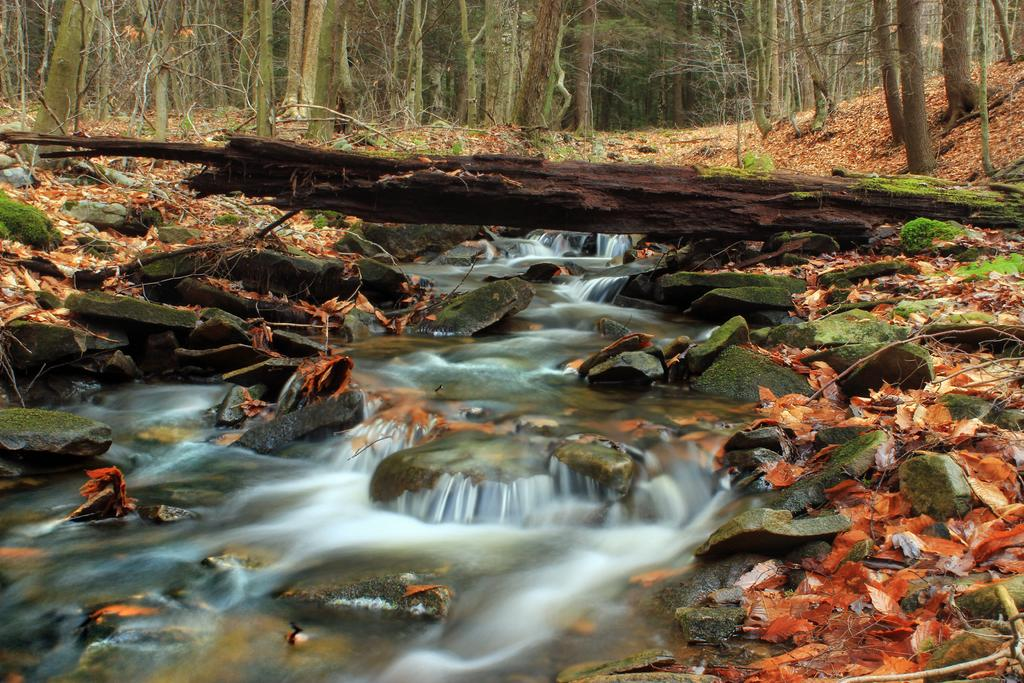What is the primary element flowing in the image? There is water flowing in the image. How is the water flowing in the image? The water is flowing over stones. What type of vegetation is near the water? There is grass near the water. Are there any other plants visible in the image? Yes, there are trees in the vicinity of the water. How many sisters are sitting on the beds near the water in the image? There are no beds or sisters present in the image; it features water flowing over stones with grass and trees nearby. 